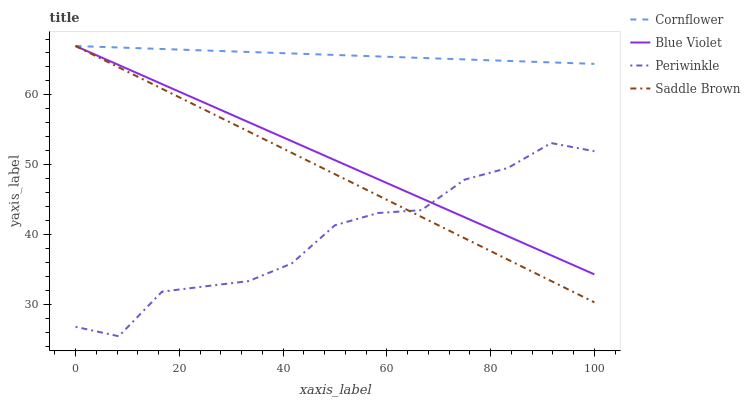Does Saddle Brown have the minimum area under the curve?
Answer yes or no. No. Does Saddle Brown have the maximum area under the curve?
Answer yes or no. No. Is Periwinkle the smoothest?
Answer yes or no. No. Is Saddle Brown the roughest?
Answer yes or no. No. Does Saddle Brown have the lowest value?
Answer yes or no. No. Does Periwinkle have the highest value?
Answer yes or no. No. Is Periwinkle less than Cornflower?
Answer yes or no. Yes. Is Cornflower greater than Periwinkle?
Answer yes or no. Yes. Does Periwinkle intersect Cornflower?
Answer yes or no. No. 